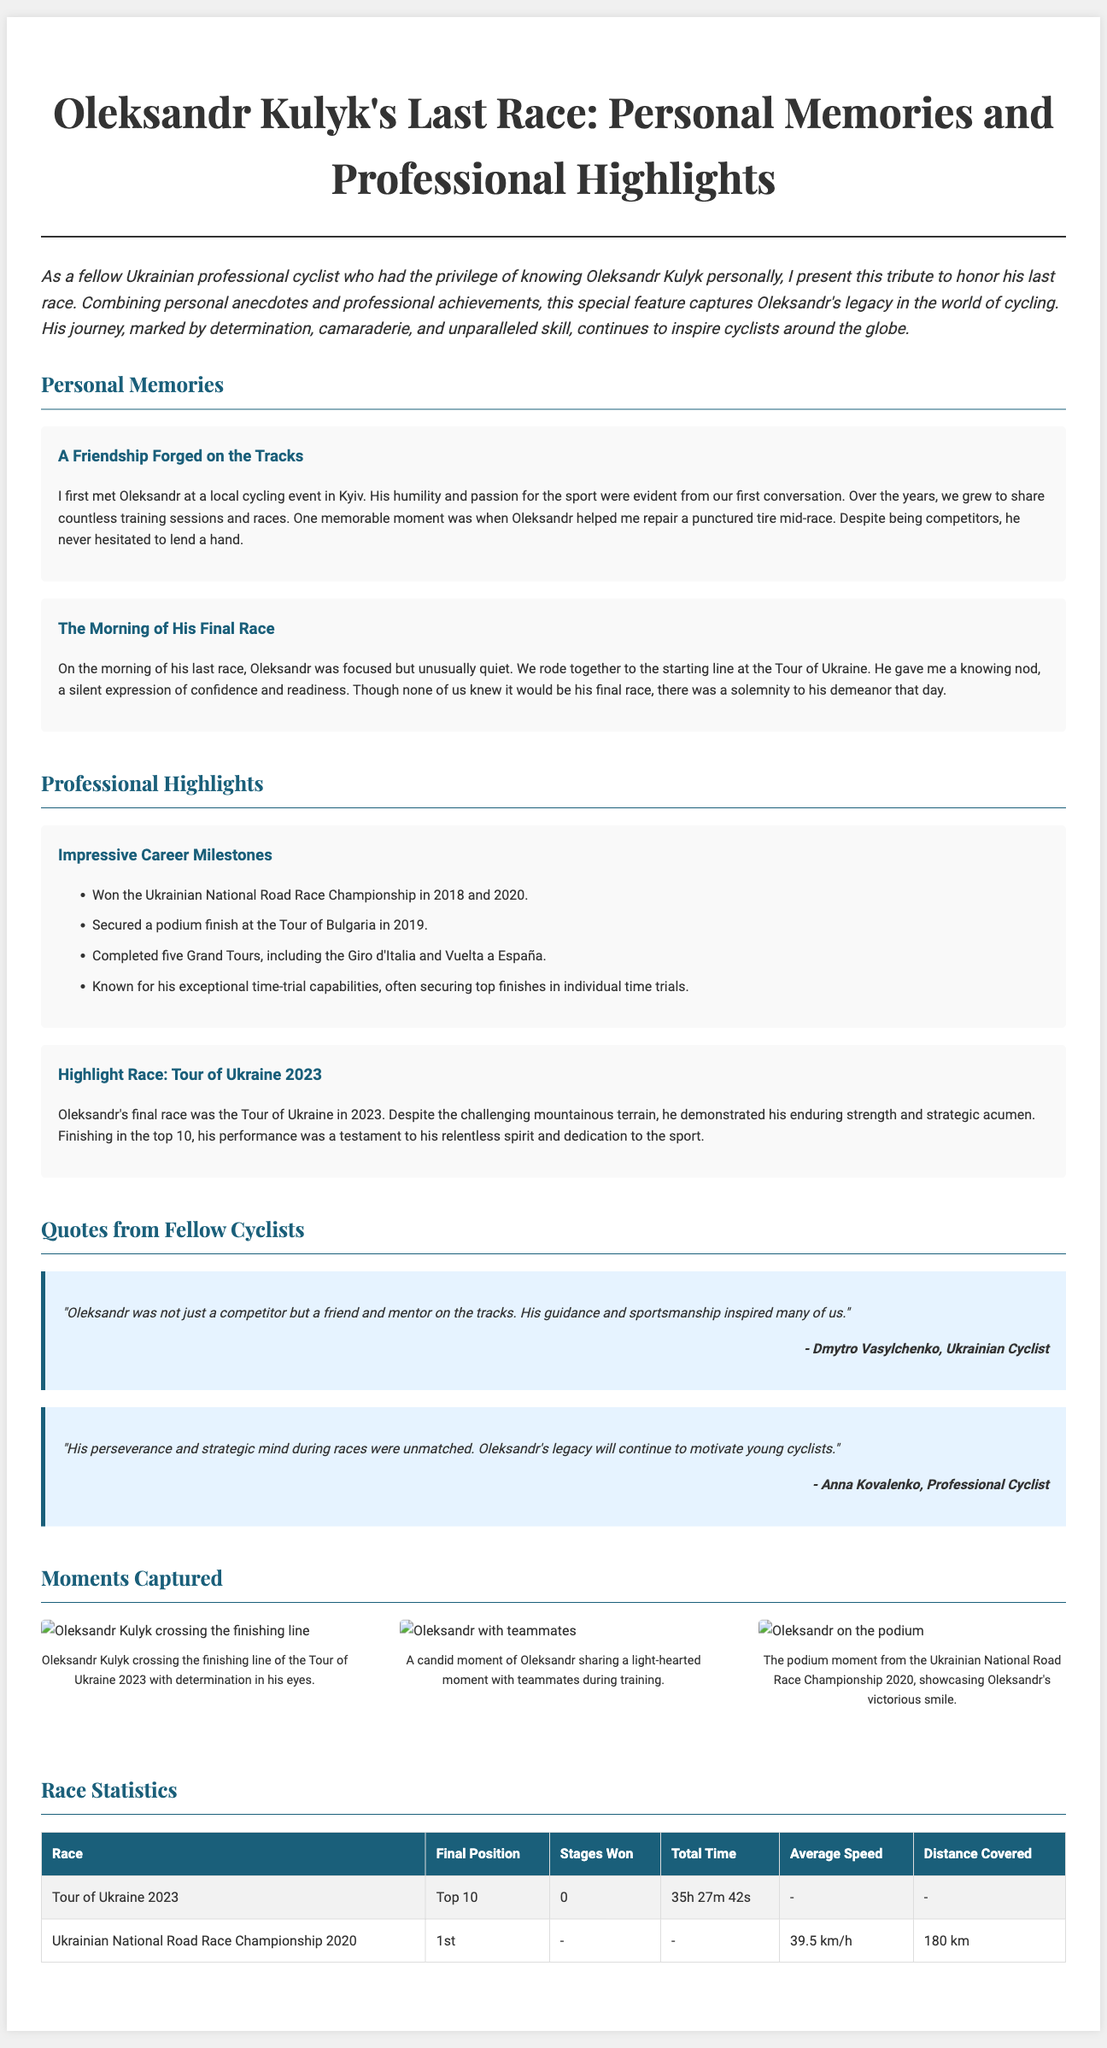What was Oleksandr Kulyk's final race? The document mentions the Tour of Ukraine 2023 as Oleksandr's final race.
Answer: Tour of Ukraine 2023 In which years did Oleksandr Kulyk win the Ukrainian National Road Race Championship? The achievements list states Oleksandr won the championship in 2018 and 2020.
Answer: 2018 and 2020 What was Oleksandr's final position in the Tour of Ukraine 2023? The race statistics indicate that he finished in the top 10 at the Tour of Ukraine 2023.
Answer: Top 10 Which cyclist mentioned Oleksandr as a friend and mentor? Dmytro Vasylchenko refers to Oleksandr as a friend and mentor in his quote.
Answer: Dmytro Vasylchenko What notable skill was Oleksandr known for? The highlights section notes his exceptional time-trial capabilities.
Answer: Time-trial What was the total time Oleksandr took in the Tour of Ukraine 2023? According to the race statistics, the total time was recorded as 35 hours, 27 minutes, and 42 seconds.
Answer: 35h 27m 42s What emotion did Oleksandr's demeanor reflect on the morning of his last race? Personal memories suggest that Oleksandr's demeanor was solemn on the morning of his last race.
Answer: Solemnity How many Grand Tours did Oleksandr complete? The document states that he completed five Grand Tours.
Answer: Five 